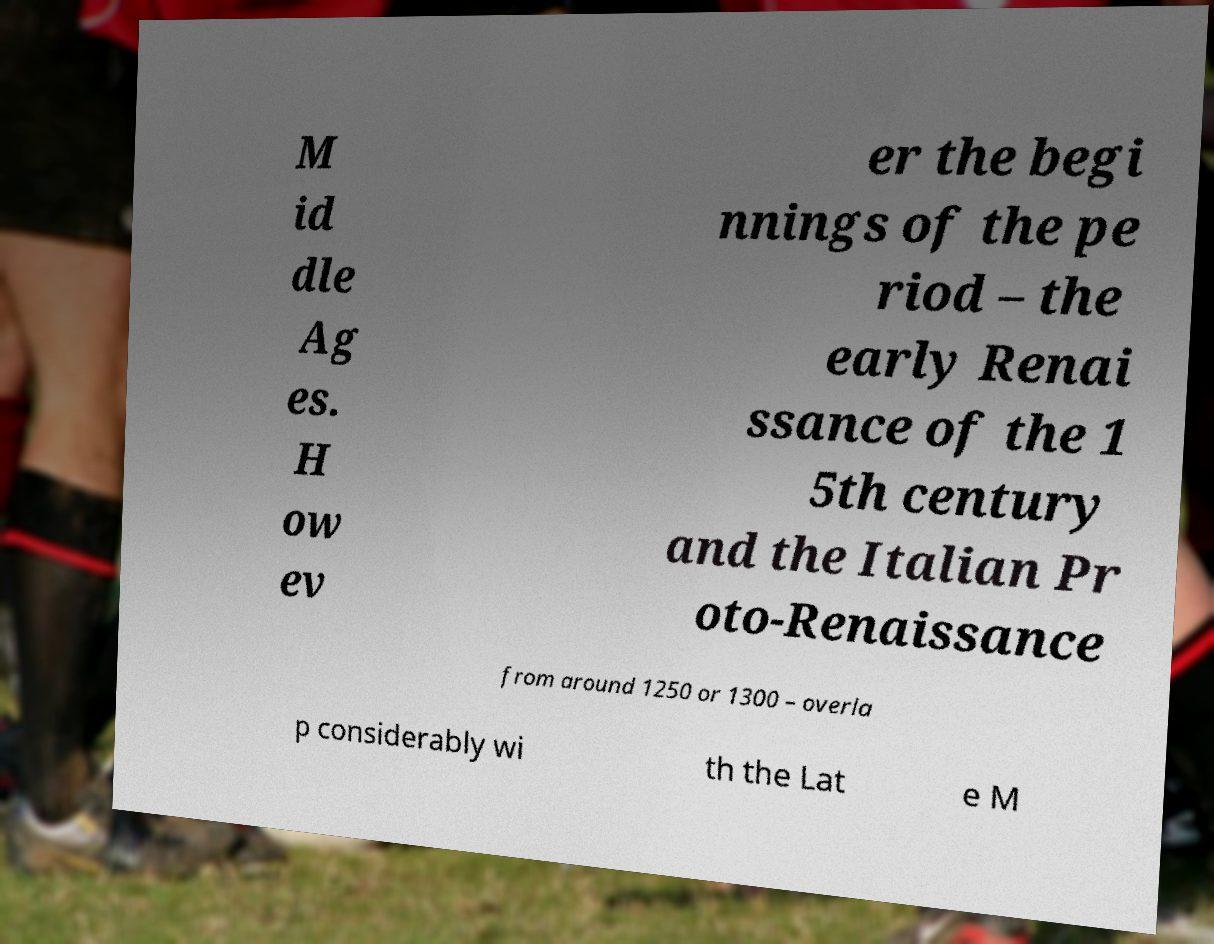Could you assist in decoding the text presented in this image and type it out clearly? M id dle Ag es. H ow ev er the begi nnings of the pe riod – the early Renai ssance of the 1 5th century and the Italian Pr oto-Renaissance from around 1250 or 1300 – overla p considerably wi th the Lat e M 